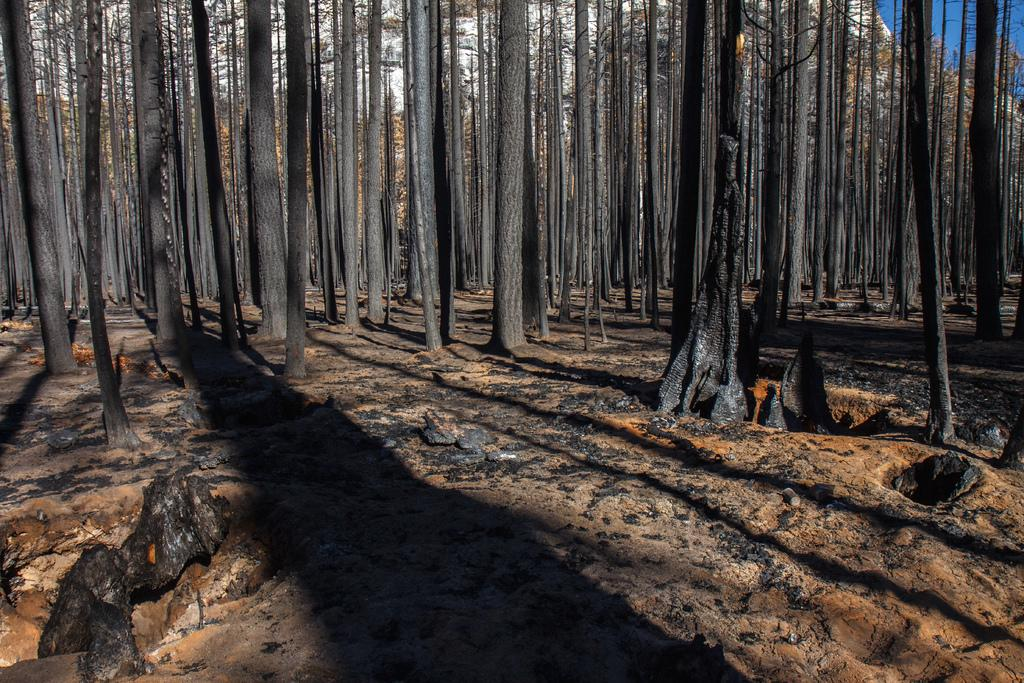What is located in the foreground of the image? There are tree trunks in the foreground of the image. What can be seen in the background of the image? The sky is visible in the background of the image. Where are the lizards hiding among the tree trunks in the image? There are no lizards present in the image; it only features tree trunks and the sky. What type of lettuce can be seen growing near the tree trunks in the image? There is no lettuce present in the image; it only features tree trunks and the sky. 